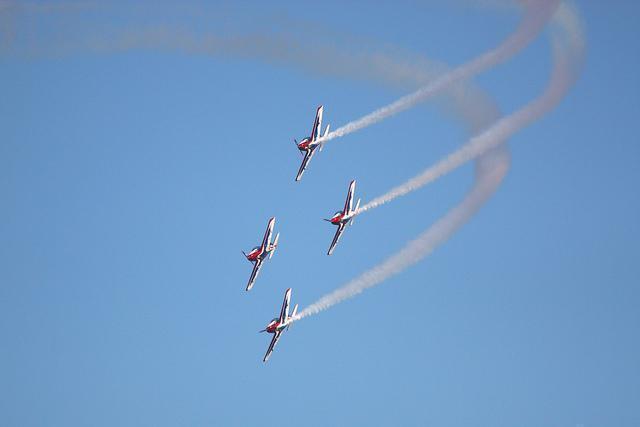The planes are executing a what?
From the following four choices, select the correct answer to address the question.
Options: Emergency landing, stunt formation, space flight, sky dive. Stunt formation. 